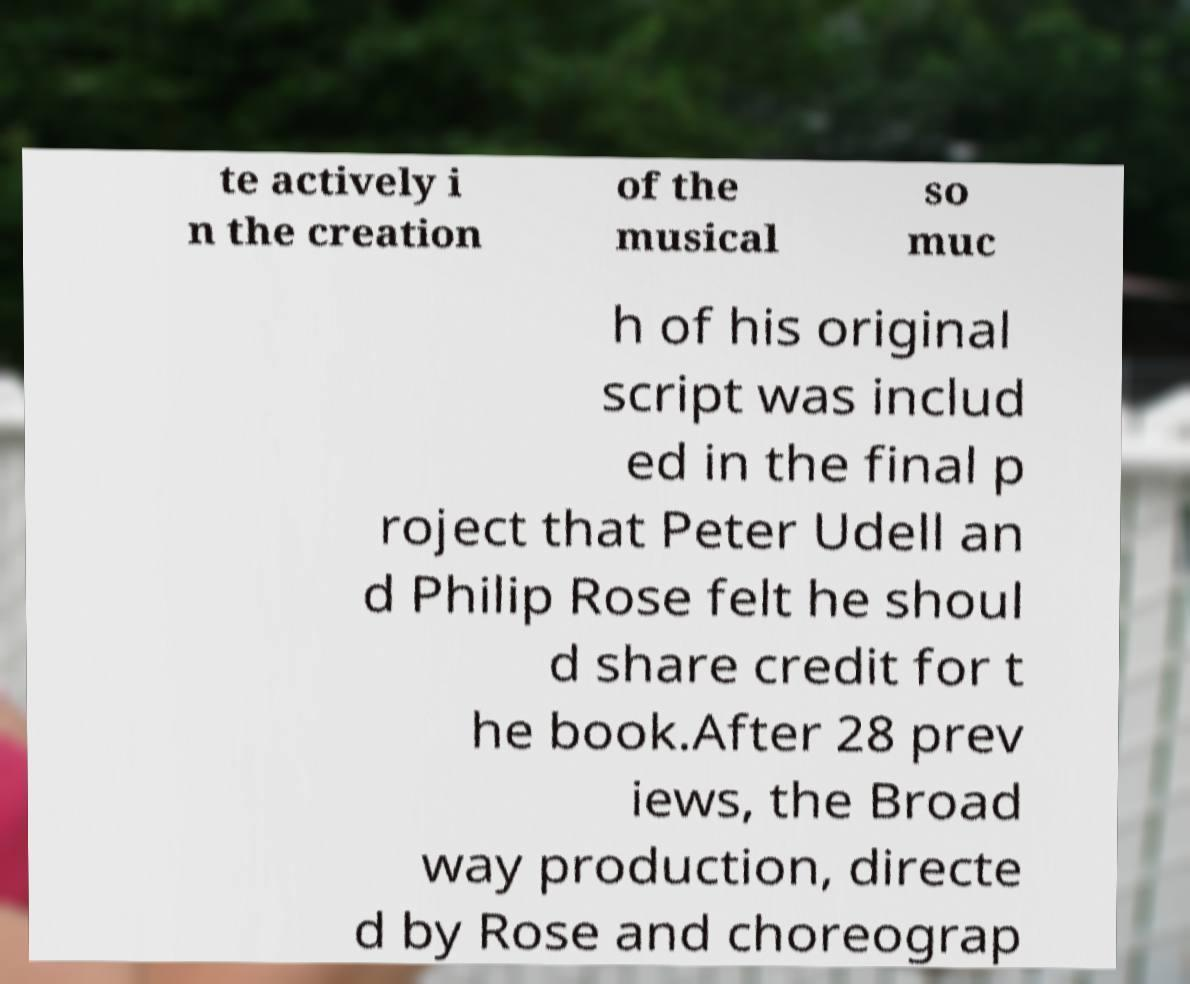I need the written content from this picture converted into text. Can you do that? te actively i n the creation of the musical so muc h of his original script was includ ed in the final p roject that Peter Udell an d Philip Rose felt he shoul d share credit for t he book.After 28 prev iews, the Broad way production, directe d by Rose and choreograp 